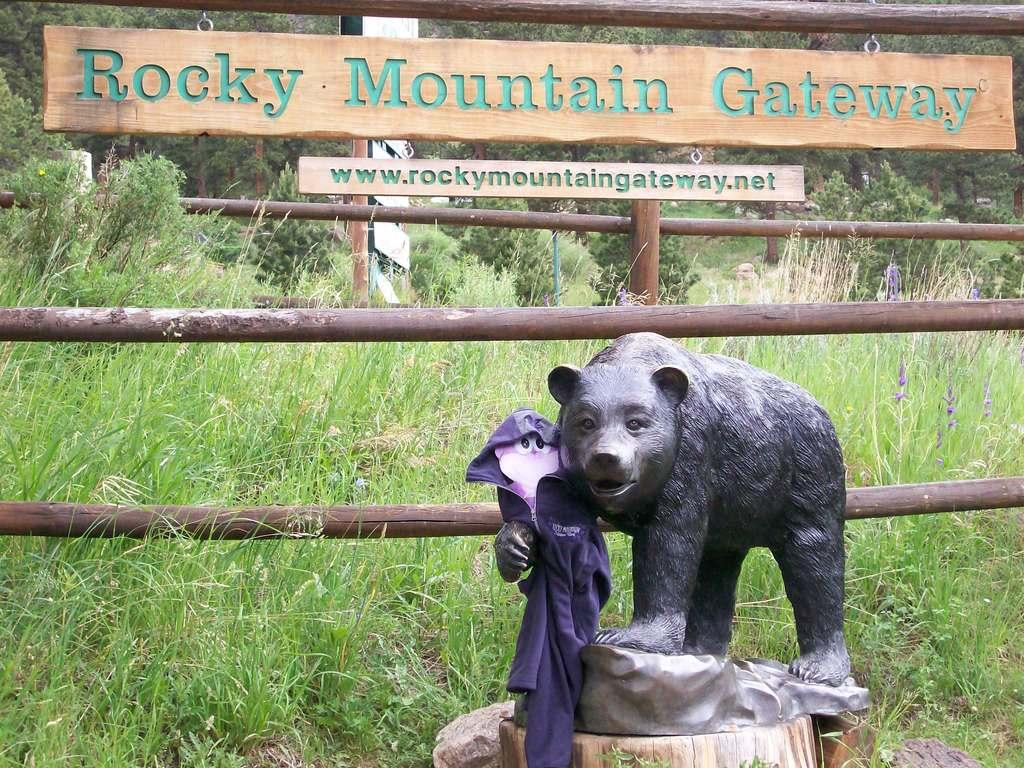What type of animal is depicted by the statue in the image? The type of animal depicted by the statue is not specified in the facts. What are the wooden poles used for in the image? The purpose of the wooden poles in the image is not mentioned in the facts. What information can be found on the boards with names in the image? The facts do not specify what information is on the boards with names. What is the natural environment visible in the background of the image? The natural environment in the background of the image includes grass and trees. What type of music is being played by the drum in the image? There is no drum present in the image, so it is not possible to determine what type of music might be played. 